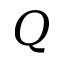Convert formula to latex. <formula><loc_0><loc_0><loc_500><loc_500>Q</formula> 